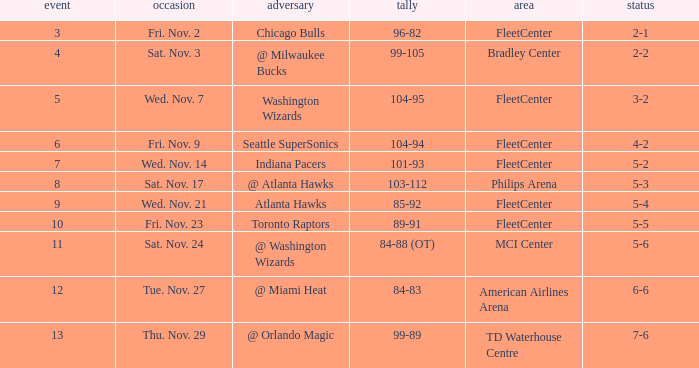On what date did Fleetcenter have a game lower than 9 with a score of 104-94? Fri. Nov. 9. 